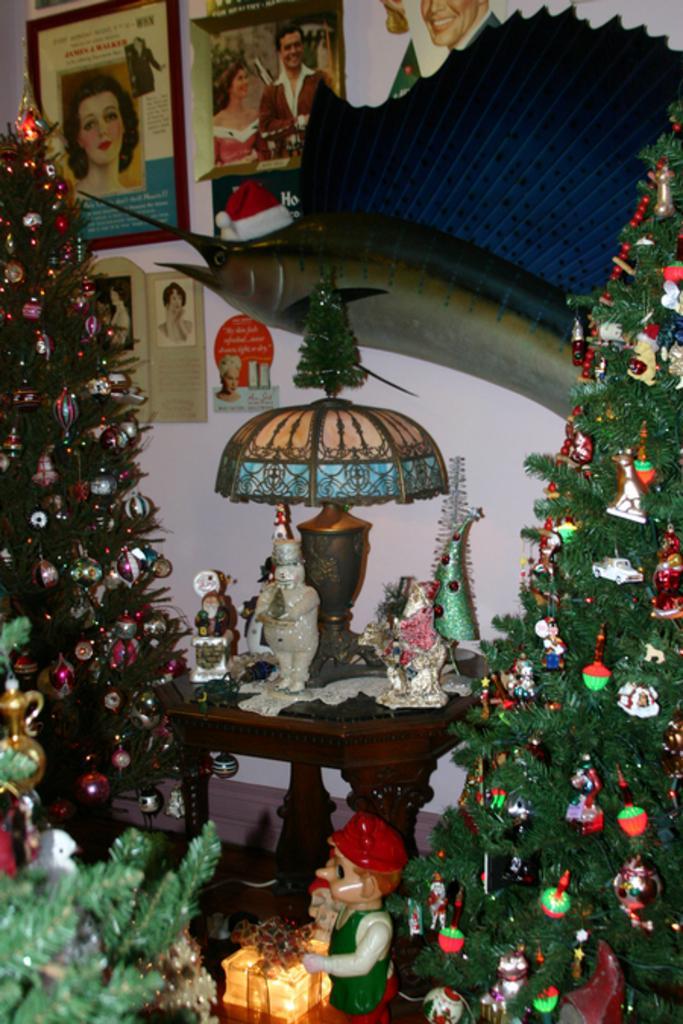In one or two sentences, can you explain what this image depicts? In this image there is a table having a lamp and few toys on it. Both sides of the table there are Christmas trees decorated with few balls and decorative items on it. Bottom of it there are few toys. Background there are few picture frames attached to the wall. Right side there is a statue near the wall. 